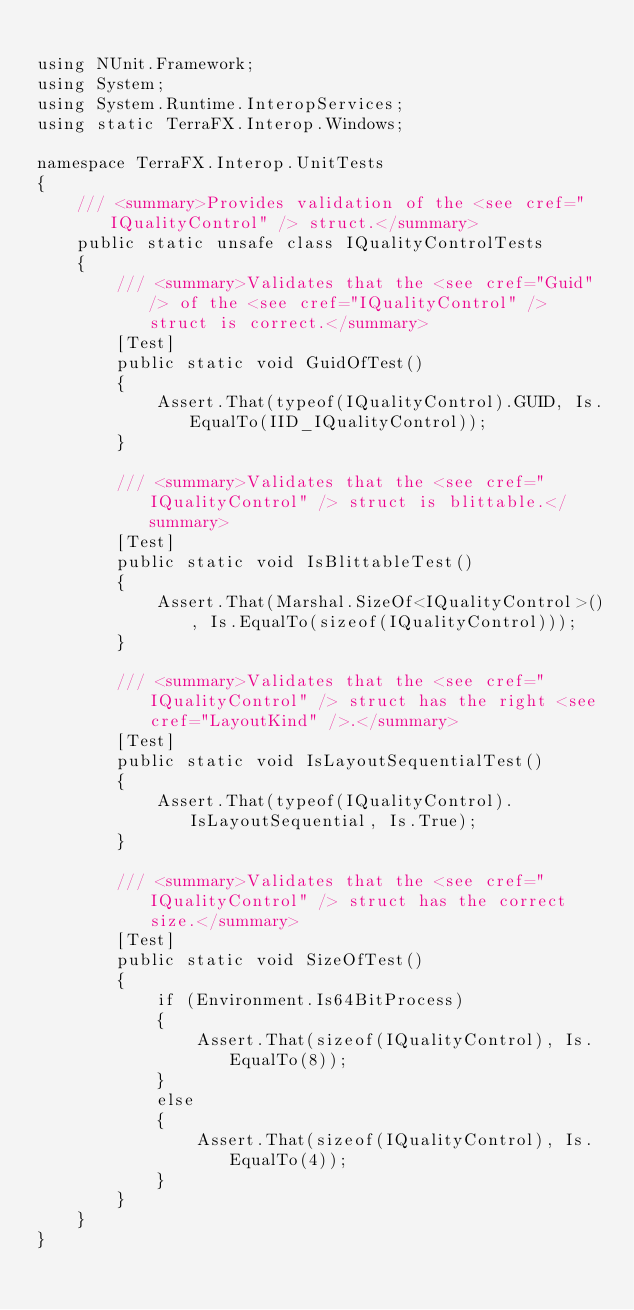<code> <loc_0><loc_0><loc_500><loc_500><_C#_>
using NUnit.Framework;
using System;
using System.Runtime.InteropServices;
using static TerraFX.Interop.Windows;

namespace TerraFX.Interop.UnitTests
{
    /// <summary>Provides validation of the <see cref="IQualityControl" /> struct.</summary>
    public static unsafe class IQualityControlTests
    {
        /// <summary>Validates that the <see cref="Guid" /> of the <see cref="IQualityControl" /> struct is correct.</summary>
        [Test]
        public static void GuidOfTest()
        {
            Assert.That(typeof(IQualityControl).GUID, Is.EqualTo(IID_IQualityControl));
        }

        /// <summary>Validates that the <see cref="IQualityControl" /> struct is blittable.</summary>
        [Test]
        public static void IsBlittableTest()
        {
            Assert.That(Marshal.SizeOf<IQualityControl>(), Is.EqualTo(sizeof(IQualityControl)));
        }

        /// <summary>Validates that the <see cref="IQualityControl" /> struct has the right <see cref="LayoutKind" />.</summary>
        [Test]
        public static void IsLayoutSequentialTest()
        {
            Assert.That(typeof(IQualityControl).IsLayoutSequential, Is.True);
        }

        /// <summary>Validates that the <see cref="IQualityControl" /> struct has the correct size.</summary>
        [Test]
        public static void SizeOfTest()
        {
            if (Environment.Is64BitProcess)
            {
                Assert.That(sizeof(IQualityControl), Is.EqualTo(8));
            }
            else
            {
                Assert.That(sizeof(IQualityControl), Is.EqualTo(4));
            }
        }
    }
}
</code> 